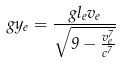Convert formula to latex. <formula><loc_0><loc_0><loc_500><loc_500>g y _ { e } = \frac { g l _ { e } v _ { e } } { \sqrt { 9 - \frac { v _ { e } ^ { 7 } } { c ^ { 7 } } } }</formula> 